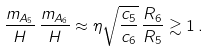<formula> <loc_0><loc_0><loc_500><loc_500>\frac { m _ { A _ { 5 } } } { H } \, \frac { m _ { A _ { 6 } } } { H } \approx \eta \sqrt { \frac { c _ { 5 } } { c _ { 6 } } } \, \frac { R _ { 6 } } { R _ { 5 } } \gtrsim 1 \, .</formula> 